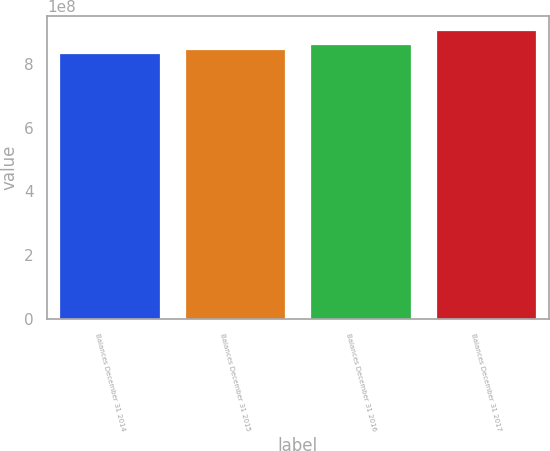<chart> <loc_0><loc_0><loc_500><loc_500><bar_chart><fcel>Balances December 31 2014<fcel>Balances December 31 2015<fcel>Balances December 31 2016<fcel>Balances December 31 2017<nl><fcel>8.34487e+08<fcel>8.45902e+08<fcel>8.62689e+08<fcel>9.04702e+08<nl></chart> 